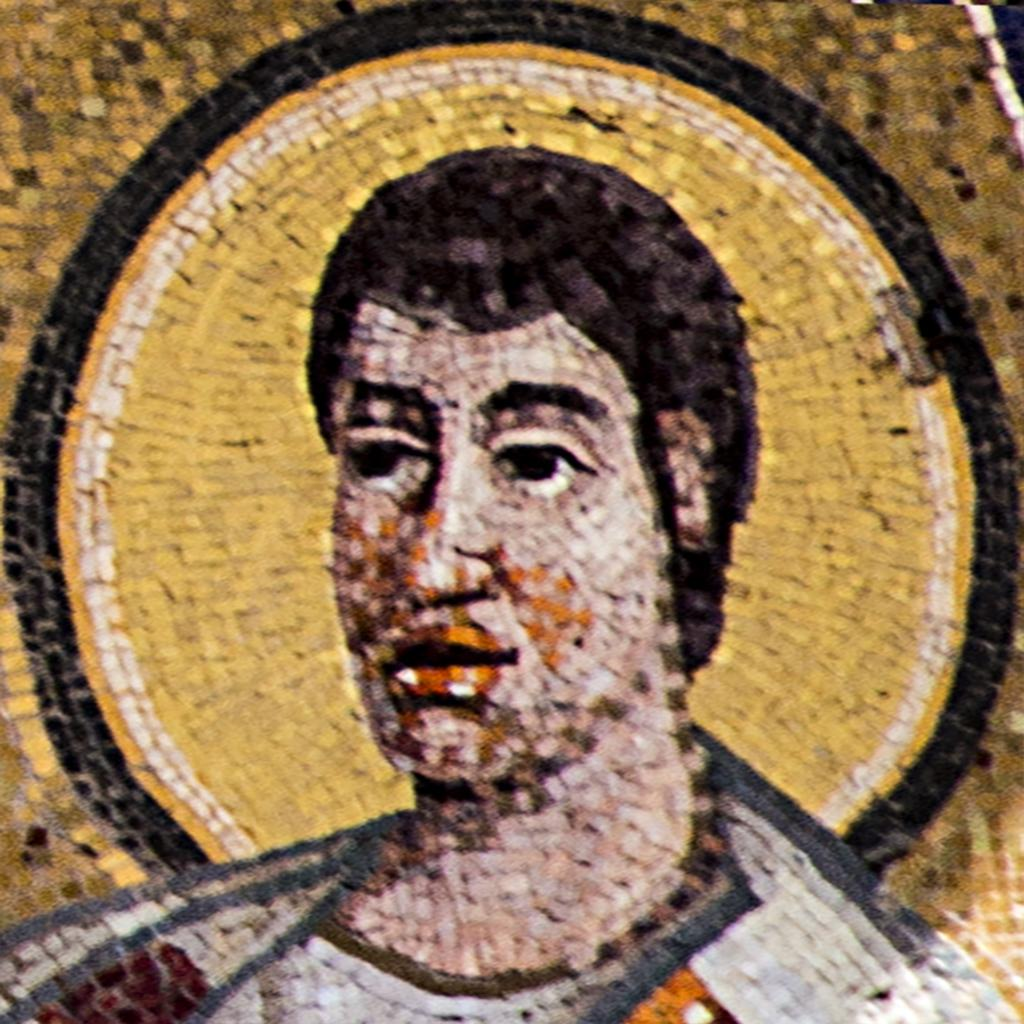What type of art is depicted in the image? There is a mosaic person art in the image. How many oranges are included in the mosaic person art? There is no information about oranges in the image, as it features a mosaic person art. 